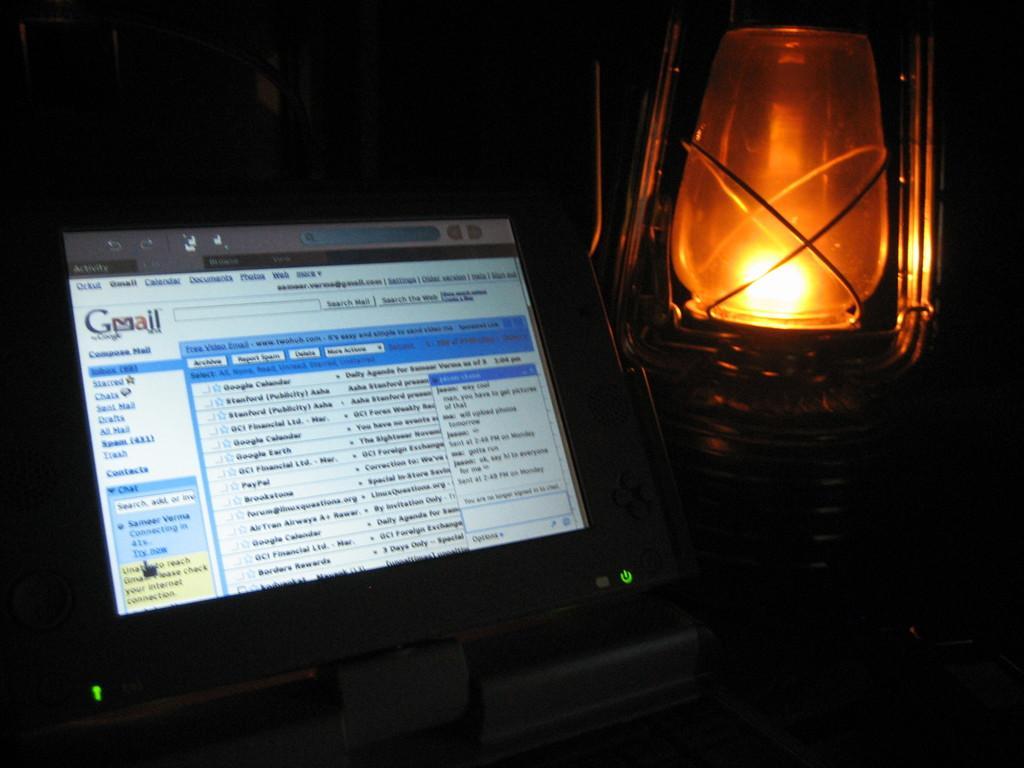Describe this image in one or two sentences. In this picture we can see a monitor, lantern and in the background it is dark. 